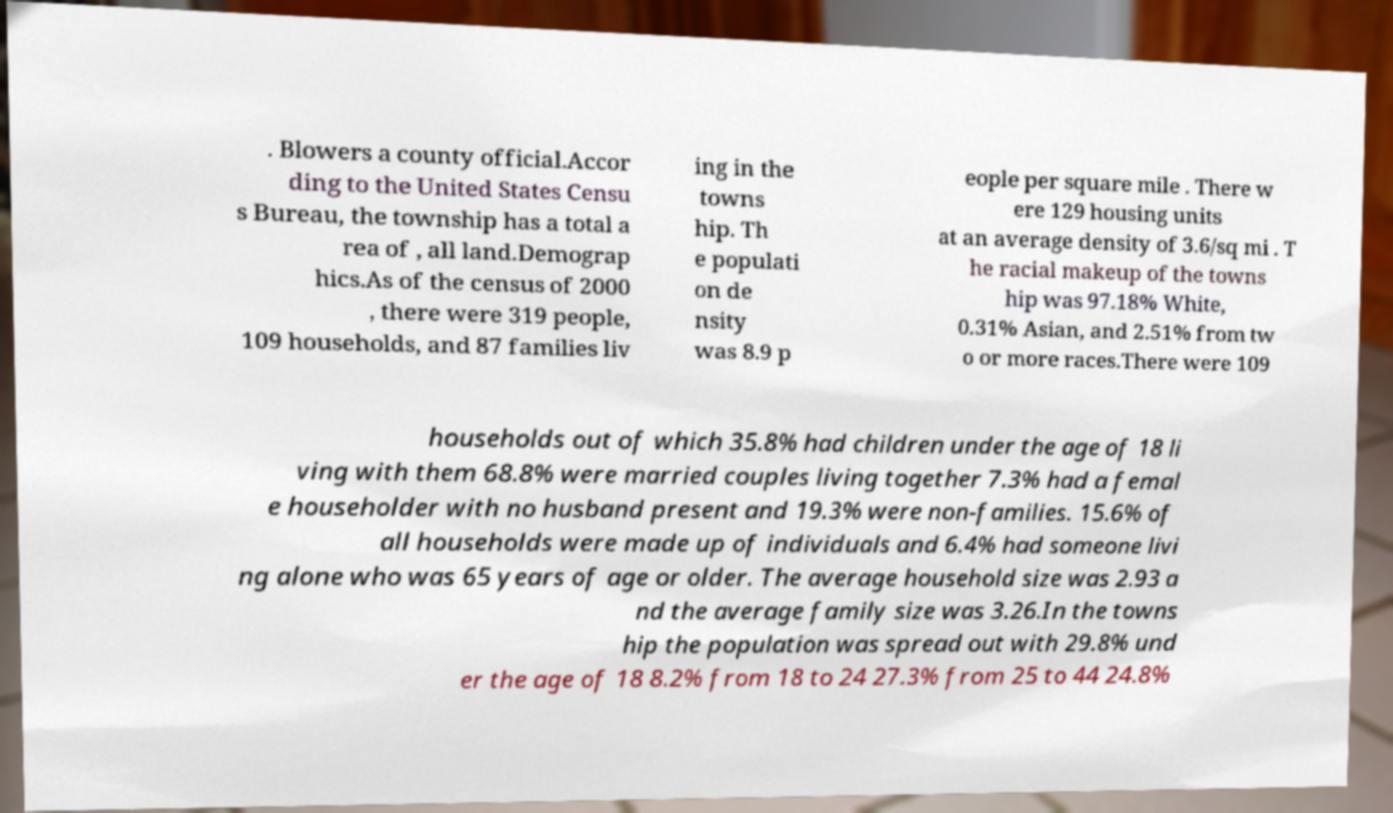Can you accurately transcribe the text from the provided image for me? . Blowers a county official.Accor ding to the United States Censu s Bureau, the township has a total a rea of , all land.Demograp hics.As of the census of 2000 , there were 319 people, 109 households, and 87 families liv ing in the towns hip. Th e populati on de nsity was 8.9 p eople per square mile . There w ere 129 housing units at an average density of 3.6/sq mi . T he racial makeup of the towns hip was 97.18% White, 0.31% Asian, and 2.51% from tw o or more races.There were 109 households out of which 35.8% had children under the age of 18 li ving with them 68.8% were married couples living together 7.3% had a femal e householder with no husband present and 19.3% were non-families. 15.6% of all households were made up of individuals and 6.4% had someone livi ng alone who was 65 years of age or older. The average household size was 2.93 a nd the average family size was 3.26.In the towns hip the population was spread out with 29.8% und er the age of 18 8.2% from 18 to 24 27.3% from 25 to 44 24.8% 